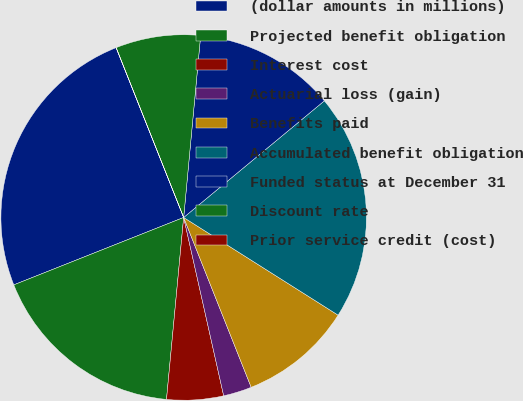Convert chart to OTSL. <chart><loc_0><loc_0><loc_500><loc_500><pie_chart><fcel>(dollar amounts in millions)<fcel>Projected benefit obligation<fcel>Interest cost<fcel>Actuarial loss (gain)<fcel>Benefits paid<fcel>Accumulated benefit obligation<fcel>Funded status at December 31<fcel>Discount rate<fcel>Prior service credit (cost)<nl><fcel>24.98%<fcel>17.49%<fcel>5.01%<fcel>2.51%<fcel>10.0%<fcel>19.99%<fcel>12.5%<fcel>7.5%<fcel>0.01%<nl></chart> 